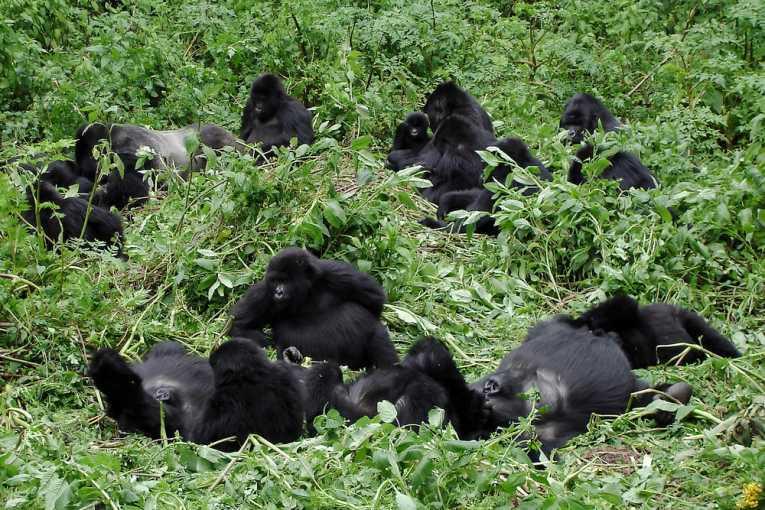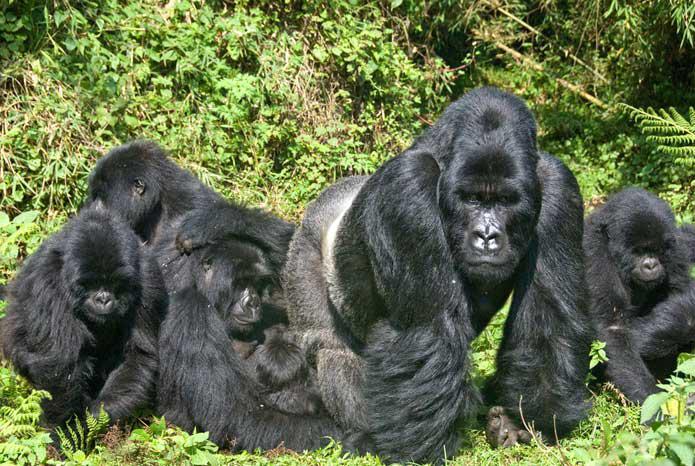The first image is the image on the left, the second image is the image on the right. Considering the images on both sides, is "There are no more than two animals in a grassy area in the image on the right." valid? Answer yes or no. No. The first image is the image on the left, the second image is the image on the right. For the images shown, is this caption "The right image contains at least three gorillas." true? Answer yes or no. Yes. 